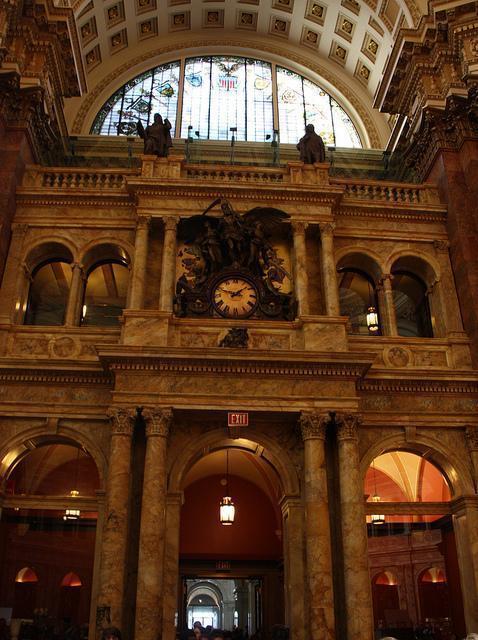What ensigns are shown at the top most part of this building?
Answer the question by selecting the correct answer among the 4 following choices.
Options: Coatsof arms, fleursdi lis, clocks, flags. Coatsof arms. 